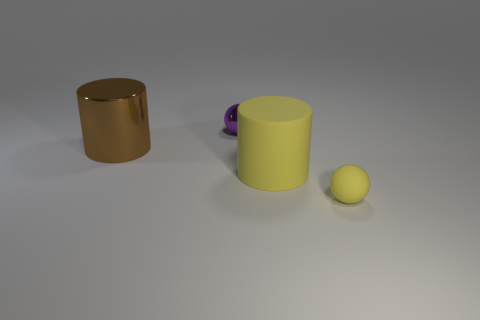Add 3 gray balls. How many objects exist? 7 Subtract 0 green balls. How many objects are left? 4 Subtract 1 cylinders. How many cylinders are left? 1 Subtract all green balls. Subtract all cyan cylinders. How many balls are left? 2 Subtract all purple cylinders. How many purple spheres are left? 1 Subtract all small purple shiny spheres. Subtract all large yellow metal cylinders. How many objects are left? 3 Add 4 tiny yellow balls. How many tiny yellow balls are left? 5 Add 1 yellow balls. How many yellow balls exist? 2 